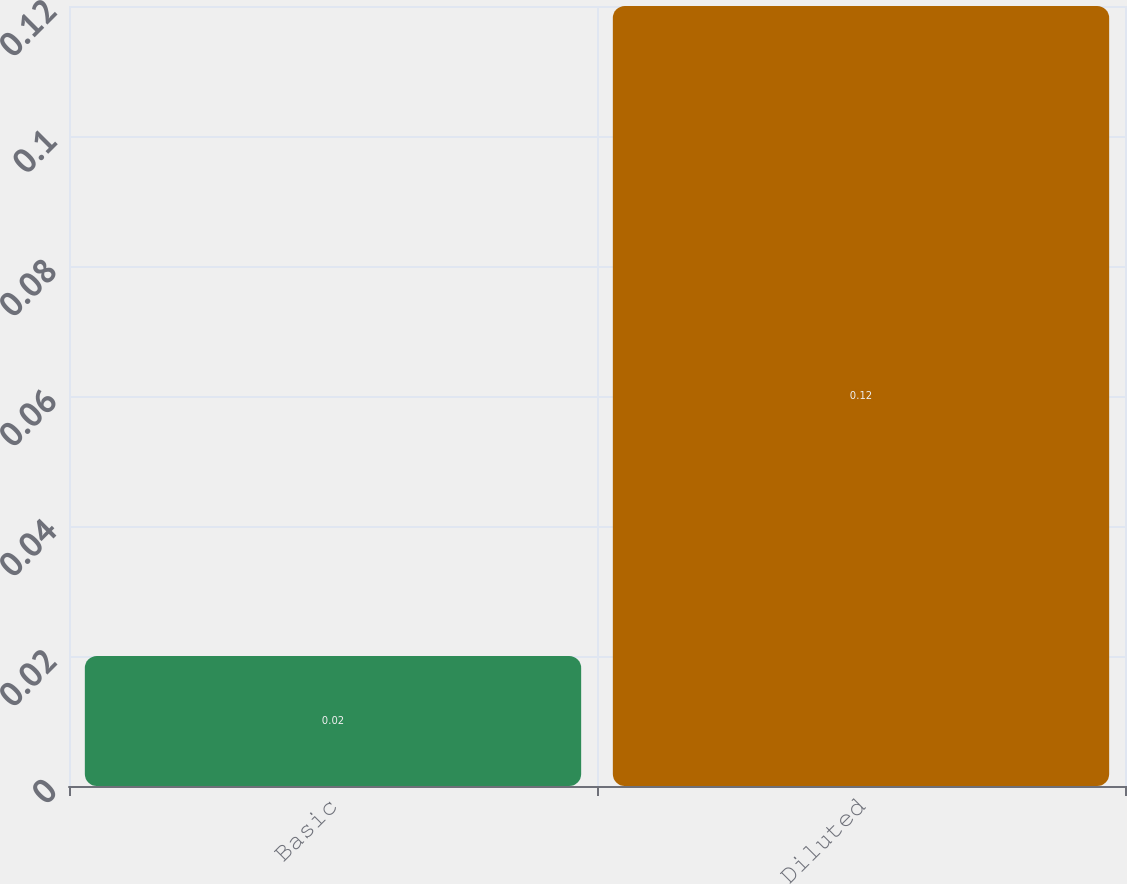Convert chart. <chart><loc_0><loc_0><loc_500><loc_500><bar_chart><fcel>Basic<fcel>Diluted<nl><fcel>0.02<fcel>0.12<nl></chart> 